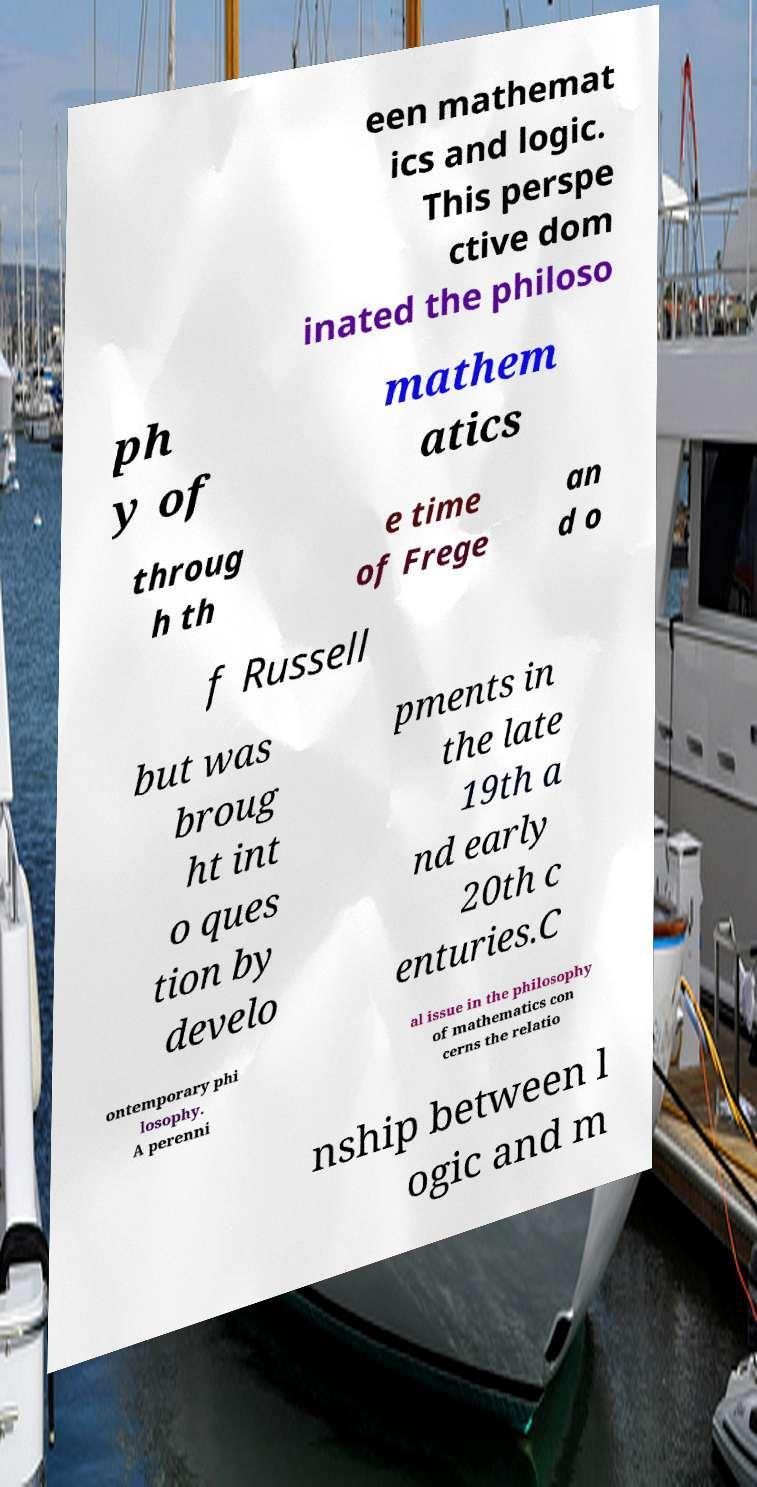Can you read and provide the text displayed in the image?This photo seems to have some interesting text. Can you extract and type it out for me? een mathemat ics and logic. This perspe ctive dom inated the philoso ph y of mathem atics throug h th e time of Frege an d o f Russell but was broug ht int o ques tion by develo pments in the late 19th a nd early 20th c enturies.C ontemporary phi losophy. A perenni al issue in the philosophy of mathematics con cerns the relatio nship between l ogic and m 